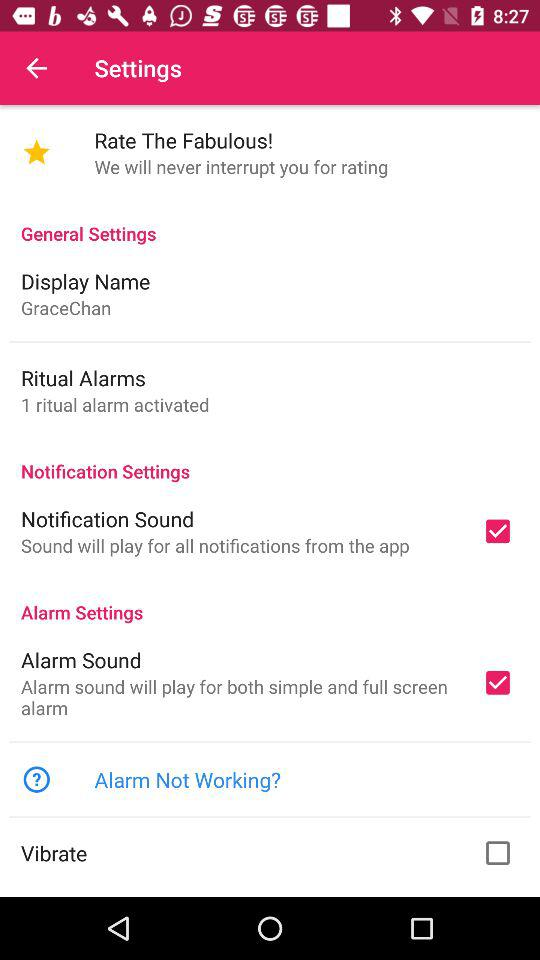What is the status of "Notification Sound"? The status is "on". 